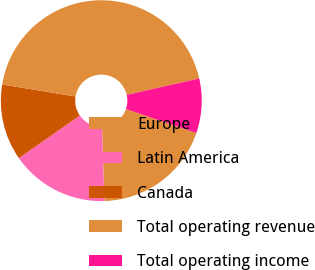Convert chart to OTSL. <chart><loc_0><loc_0><loc_500><loc_500><pie_chart><fcel>Europe<fcel>Latin America<fcel>Canada<fcel>Total operating revenue<fcel>Total operating income<nl><fcel>19.3%<fcel>15.79%<fcel>12.27%<fcel>43.88%<fcel>8.76%<nl></chart> 